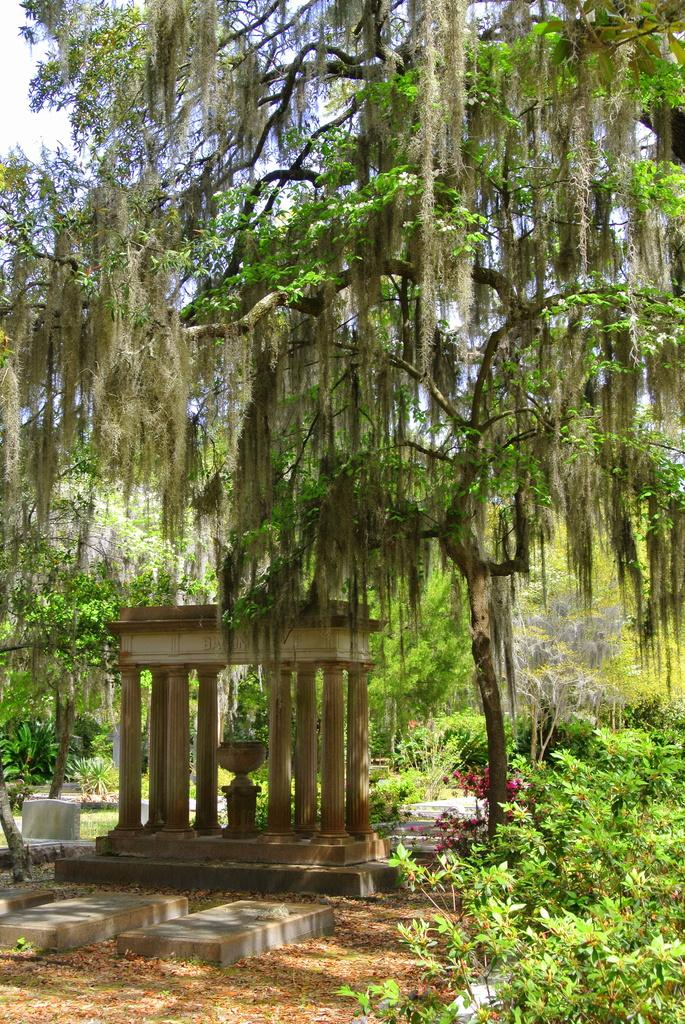What is the sky is visible in the center of the image, what else can be seen? Clouds are present in the image. Trees, plants, stones, pillars, an outdoor structure, and a pot are also visible. What type of vegetation is present in the image? Trees and plants are present in the image. What type of material are the stones made of? The stones are made of a solid, natural material. What is the outdoor structure in the image? The outdoor structure is not specified, but it is mentioned that there is an outdoor structure in the image. What is the purpose of the pot in the image? The purpose of the pot is not specified, but it is mentioned that there is a pot in the image. How many other objects are in the image? There are a few other objects in the image, but the exact number is not specified. What type of popcorn is being served at the birthday party in the image? There is no mention of a birthday party or popcorn in the image. 